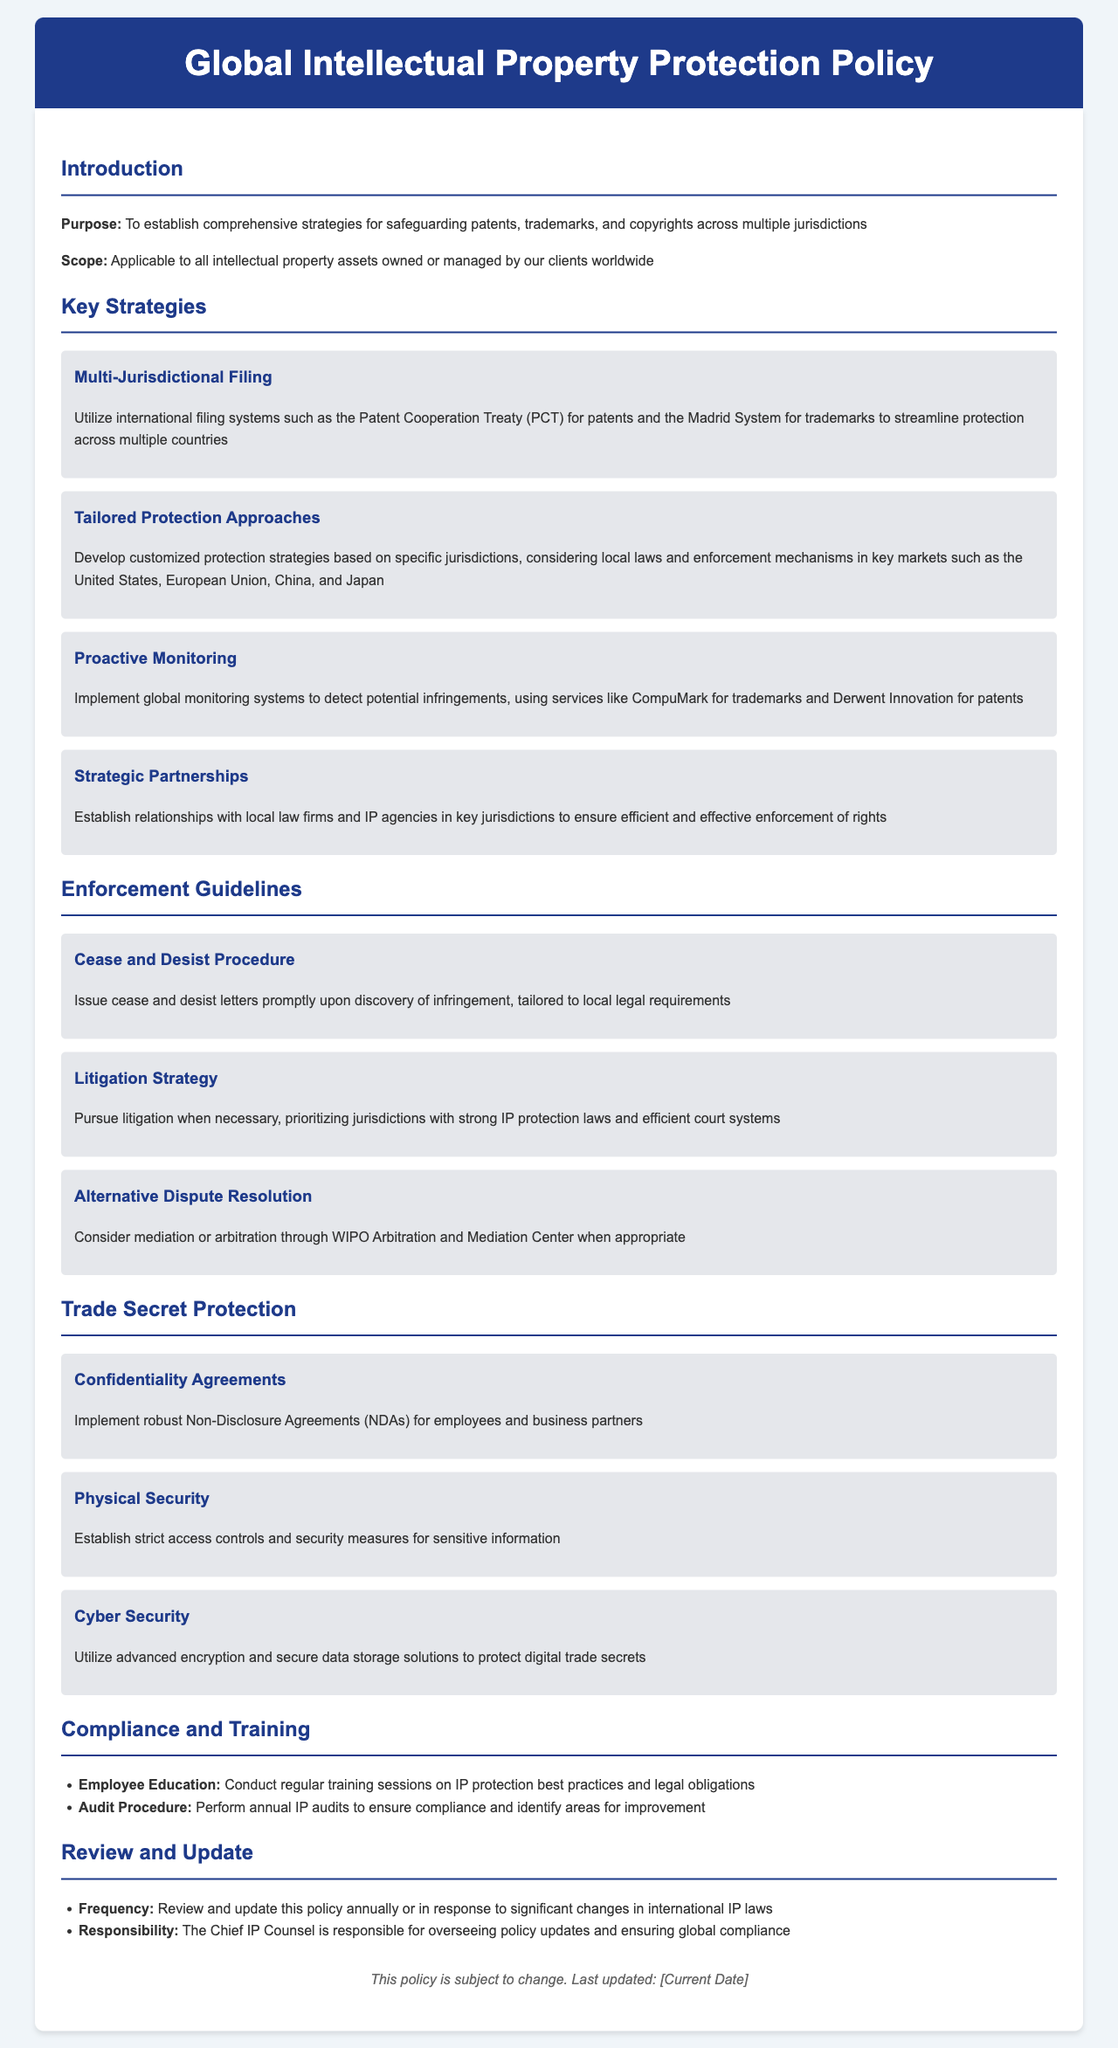What is the purpose of the policy? The purpose is to establish comprehensive strategies for safeguarding patents, trademarks, and copyrights across multiple jurisdictions.
Answer: To establish comprehensive strategies for safeguarding patents, trademarks, and copyrights across multiple jurisdictions Which filing system is recommended for patents? The document mentions utilizing the Patent Cooperation Treaty (PCT) for patents.
Answer: Patent Cooperation Treaty (PCT) What is a key element of the monitoring strategy? The document suggests implementing global monitoring systems to detect potential infringements.
Answer: Implementing global monitoring systems What should be considered for tailored protection approaches? Tailored protection approaches should consider local laws and enforcement mechanisms in key markets.
Answer: Local laws and enforcement mechanisms Who is responsible for overseeing policy updates? The document states that the Chief IP Counsel is responsible for overseeing policy updates.
Answer: Chief IP Counsel What type of agreements should be implemented for trade secret protection? For trade secret protection, the document mentions implementing Non-Disclosure Agreements (NDAs).
Answer: Non-Disclosure Agreements (NDAs) How often should the policy be reviewed? The policy should be reviewed annually or in response to significant changes in international IP laws.
Answer: Annually What method is suggested for alternative dispute resolution? The policy suggests considering mediation or arbitration through the WIPO Arbitration and Mediation Center.
Answer: WIPO Arbitration and Mediation Center 